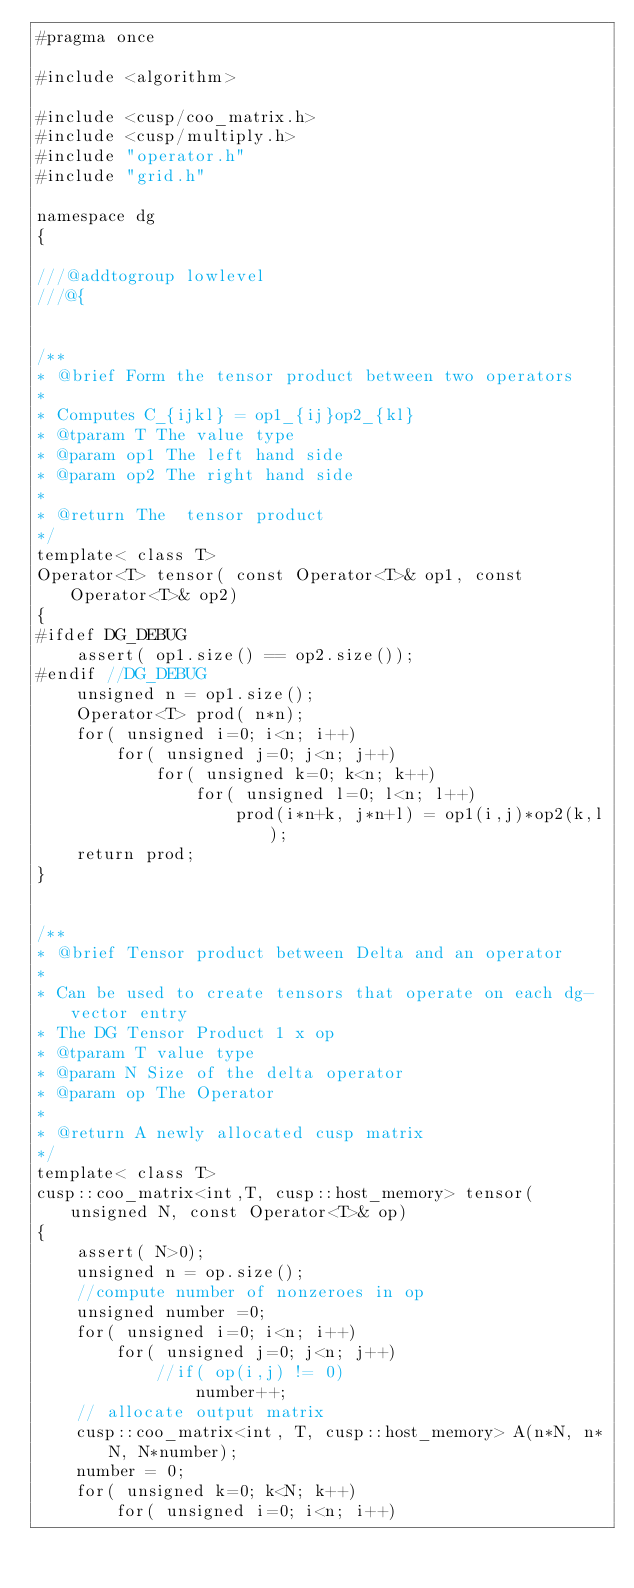Convert code to text. <code><loc_0><loc_0><loc_500><loc_500><_Cuda_>#pragma once 

#include <algorithm>

#include <cusp/coo_matrix.h>
#include <cusp/multiply.h>
#include "operator.h"
#include "grid.h"

namespace dg
{

///@addtogroup lowlevel
///@{


/**
* @brief Form the tensor product between two operators
*
* Computes C_{ijkl} = op1_{ij}op2_{kl}
* @tparam T The value type
* @param op1 The left hand side
* @param op2 The right hand side
*
* @return The  tensor product
*/
template< class T>
Operator<T> tensor( const Operator<T>& op1, const Operator<T>& op2)
{
#ifdef DG_DEBUG
    assert( op1.size() == op2.size());
#endif //DG_DEBUG
    unsigned n = op1.size();
    Operator<T> prod( n*n);
    for( unsigned i=0; i<n; i++)
        for( unsigned j=0; j<n; j++)
            for( unsigned k=0; k<n; k++)
                for( unsigned l=0; l<n; l++)
                    prod(i*n+k, j*n+l) = op1(i,j)*op2(k,l);
    return prod;
}


/**
* @brief Tensor product between Delta and an operator
*
* Can be used to create tensors that operate on each dg-vector entry
* The DG Tensor Product 1 x op
* @tparam T value type
* @param N Size of the delta operator
* @param op The Operator
*
* @return A newly allocated cusp matrix
*/
template< class T>
cusp::coo_matrix<int,T, cusp::host_memory> tensor( unsigned N, const Operator<T>& op)
{
    assert( N>0);
    unsigned n = op.size();
    //compute number of nonzeroes in op
    unsigned number =0;
    for( unsigned i=0; i<n; i++)
        for( unsigned j=0; j<n; j++)
            //if( op(i,j) != 0)
                number++;
    // allocate output matrix
    cusp::coo_matrix<int, T, cusp::host_memory> A(n*N, n*N, N*number);
    number = 0;
    for( unsigned k=0; k<N; k++)
        for( unsigned i=0; i<n; i++)</code> 